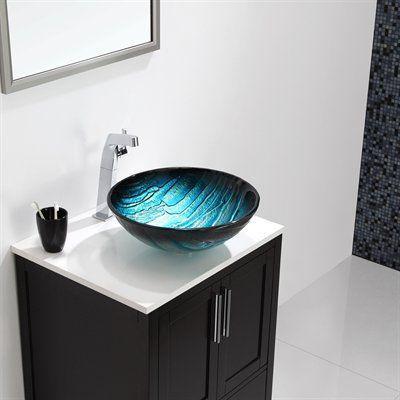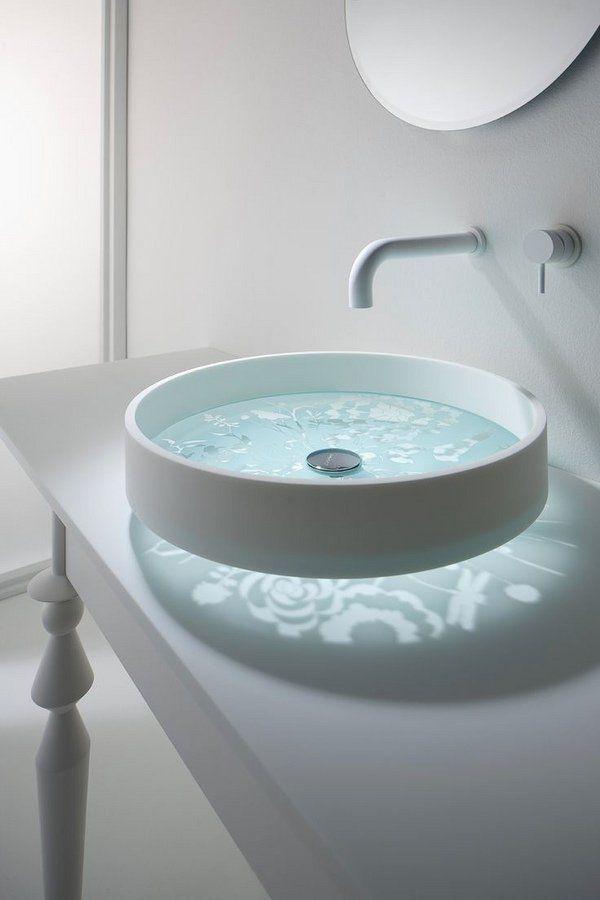The first image is the image on the left, the second image is the image on the right. Given the left and right images, does the statement "Sinks on the left and right share the same shape and faucet style." hold true? Answer yes or no. No. The first image is the image on the left, the second image is the image on the right. Examine the images to the left and right. Is the description "There is an item next to a sink." accurate? Answer yes or no. Yes. 